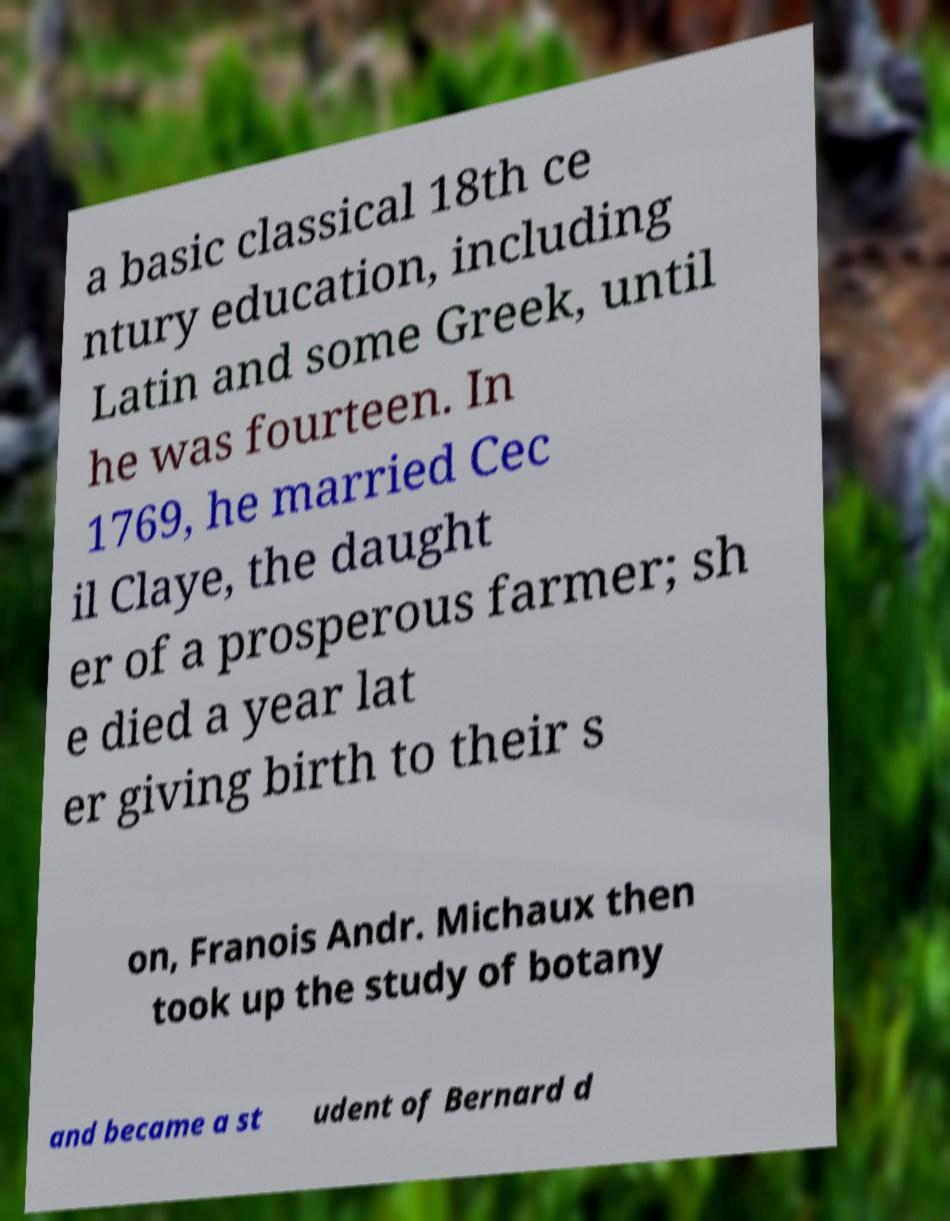What messages or text are displayed in this image? I need them in a readable, typed format. a basic classical 18th ce ntury education, including Latin and some Greek, until he was fourteen. In 1769, he married Cec il Claye, the daught er of a prosperous farmer; sh e died a year lat er giving birth to their s on, Franois Andr. Michaux then took up the study of botany and became a st udent of Bernard d 